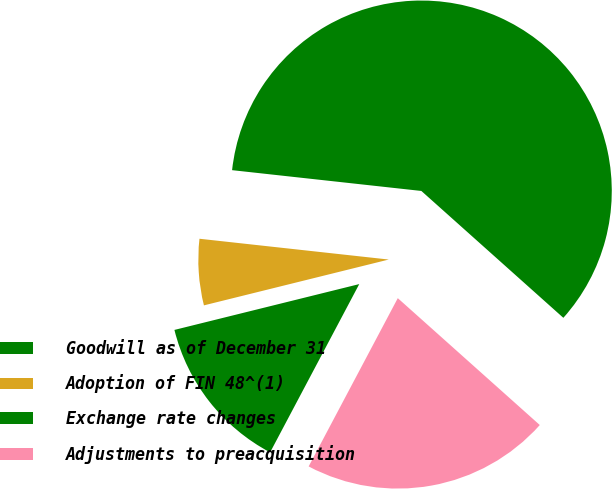Convert chart. <chart><loc_0><loc_0><loc_500><loc_500><pie_chart><fcel>Goodwill as of December 31<fcel>Adoption of FIN 48^(1)<fcel>Exchange rate changes<fcel>Adjustments to preacquisition<nl><fcel>59.87%<fcel>5.61%<fcel>13.38%<fcel>21.15%<nl></chart> 